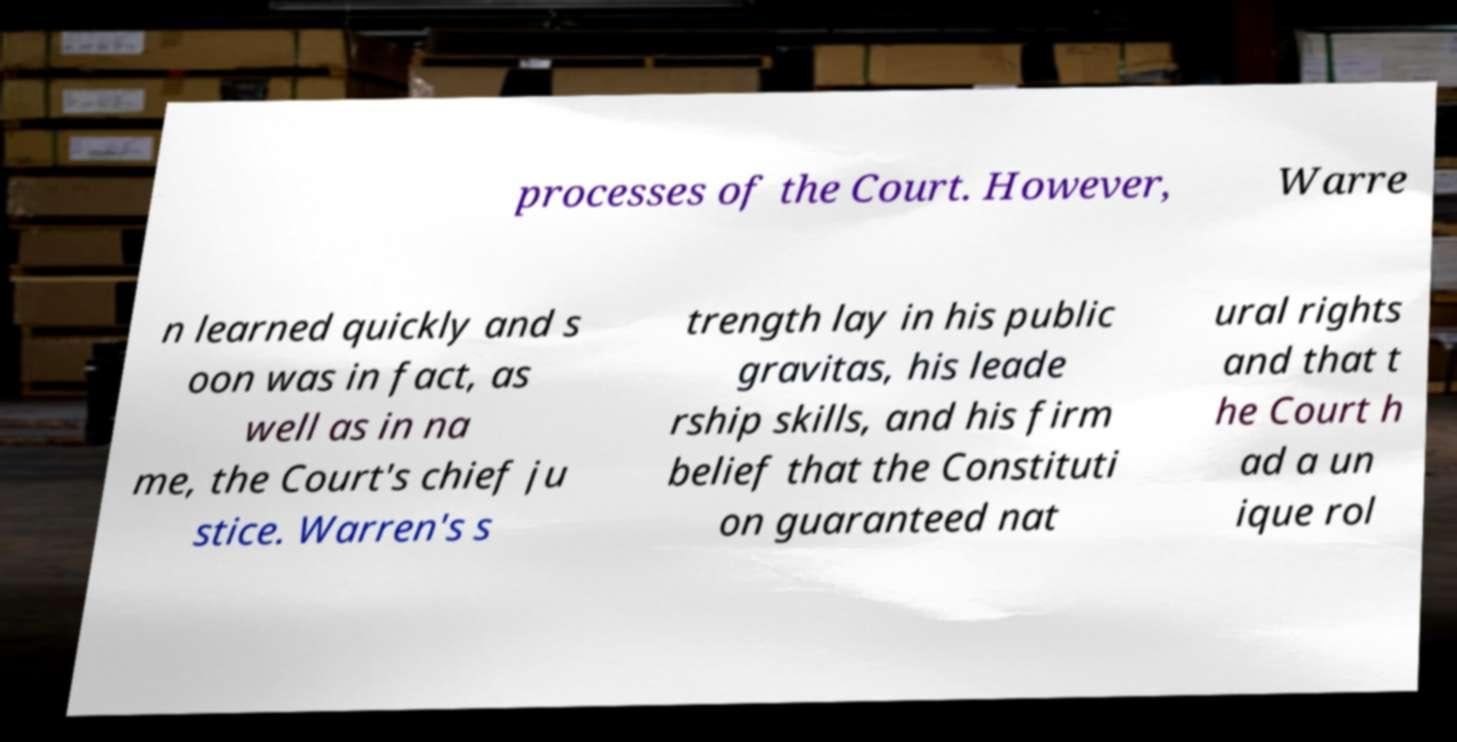Please read and relay the text visible in this image. What does it say? processes of the Court. However, Warre n learned quickly and s oon was in fact, as well as in na me, the Court's chief ju stice. Warren's s trength lay in his public gravitas, his leade rship skills, and his firm belief that the Constituti on guaranteed nat ural rights and that t he Court h ad a un ique rol 